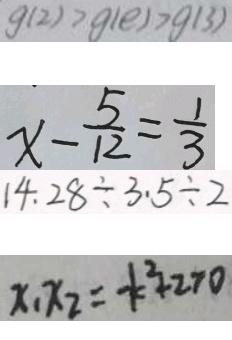<formula> <loc_0><loc_0><loc_500><loc_500>g ( 2 ) > g ( e ) > g ( 3 ) 
 x - \frac { 5 } { 1 2 } = \frac { 1 } { 3 } 
 1 4 . 2 8 \div 3 . 5 \div 2 
 x _ { 1 } x _ { 2 } = - k ^ { 2 } + 2 > 0</formula> 